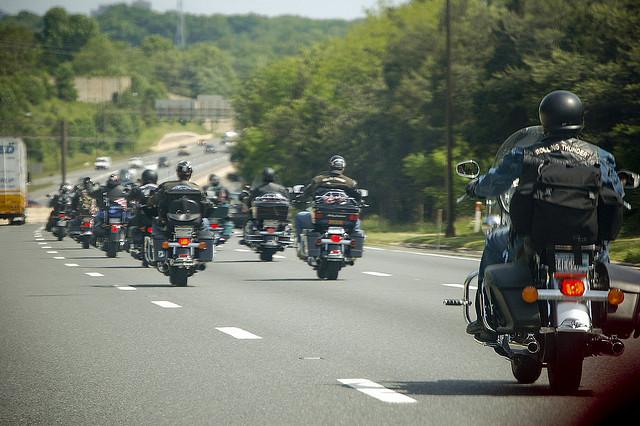How many helmets are there?
Write a very short answer. 12. How many motorcycles are present?
Keep it brief. 20. What color are the lights?
Keep it brief. Red. How many wheels do you see?
Write a very short answer. 10. What is the license plate number?
Answer briefly. 401ks. Will these motorcycles hold multiple people?
Write a very short answer. Yes. What color are the stripes on the street?
Give a very brief answer. White. What is the license plate of the far right motorcycle?
Be succinct. M396. Is this in the city?
Keep it brief. No. How many mirrors do you see?
Short answer required. 3. Can you make out the bikers tag?
Write a very short answer. No. How many more bikes than people?
Answer briefly. 0. Are people riding the motorcycles?
Give a very brief answer. Yes. Who is the man on the bike?
Answer briefly. Biker. What color is the parking lot stripe?
Write a very short answer. White. Are the motorcycles parked?
Concise answer only. No. How many motorcycles are there?
Quick response, please. 15. What number of motorcycles are driving down the street?
Answer briefly. 20. How many bike riders are there?
Keep it brief. 12. How many motorcycle riders are there?
Be succinct. 10. Do all the bikers have their feet on the ground?
Answer briefly. No. Is he in a parade?
Be succinct. No. Are these motorcycles going fast?
Give a very brief answer. Yes. Are the people on motorcycles cops?
Quick response, please. No. 